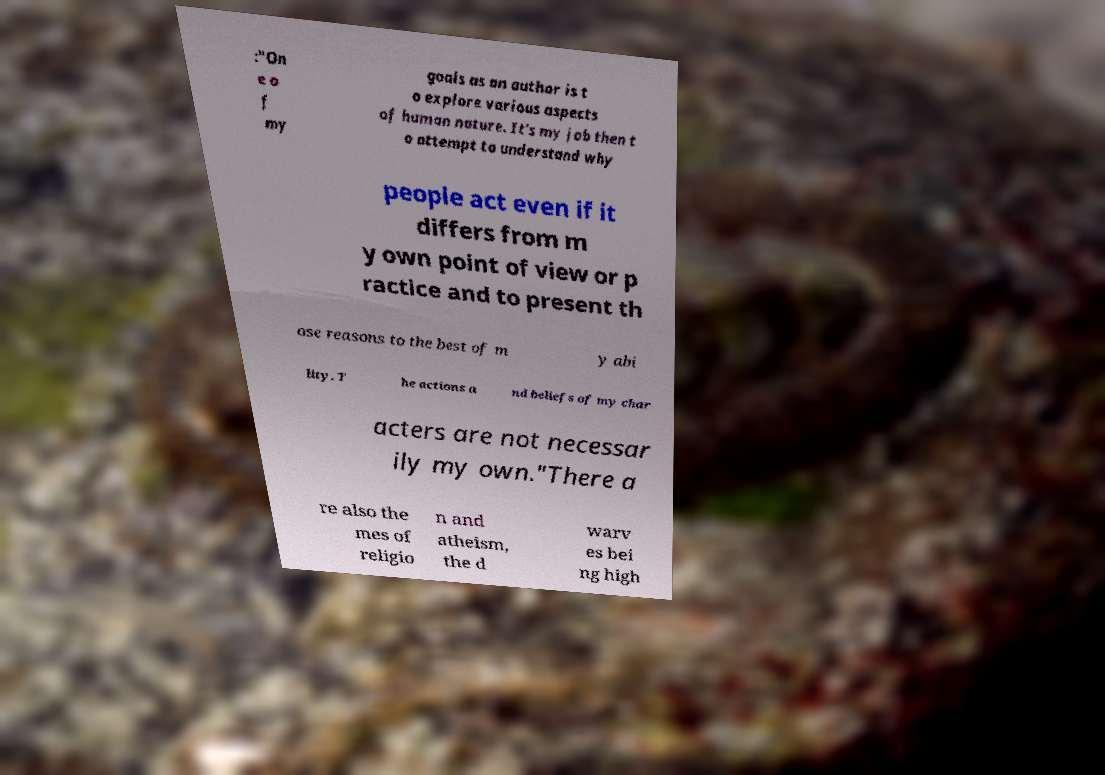For documentation purposes, I need the text within this image transcribed. Could you provide that? :"On e o f my goals as an author is t o explore various aspects of human nature. It's my job then t o attempt to understand why people act even if it differs from m y own point of view or p ractice and to present th ose reasons to the best of m y abi lity. T he actions a nd beliefs of my char acters are not necessar ily my own."There a re also the mes of religio n and atheism, the d warv es bei ng high 